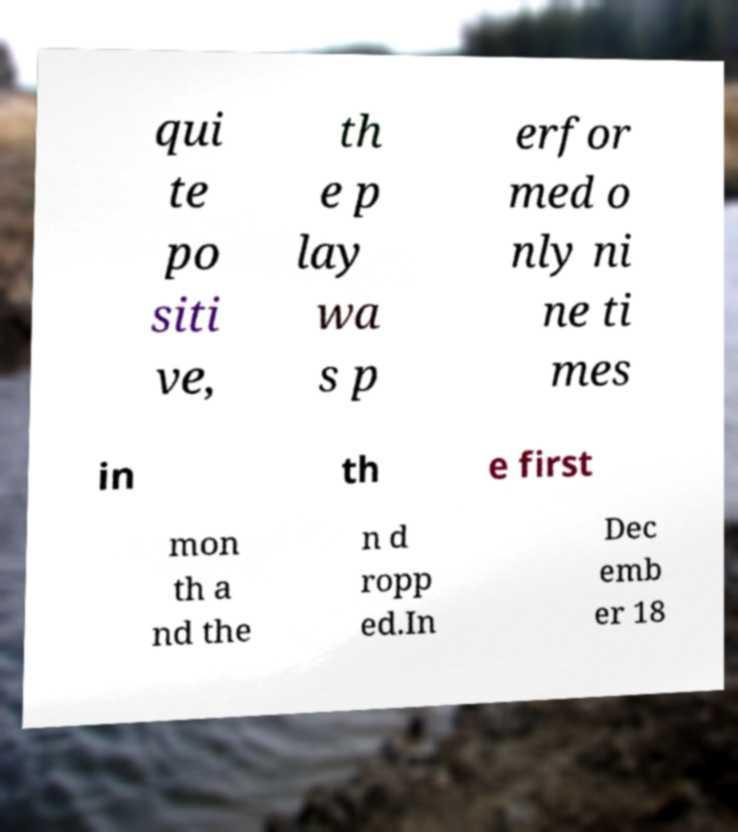I need the written content from this picture converted into text. Can you do that? qui te po siti ve, th e p lay wa s p erfor med o nly ni ne ti mes in th e first mon th a nd the n d ropp ed.In Dec emb er 18 